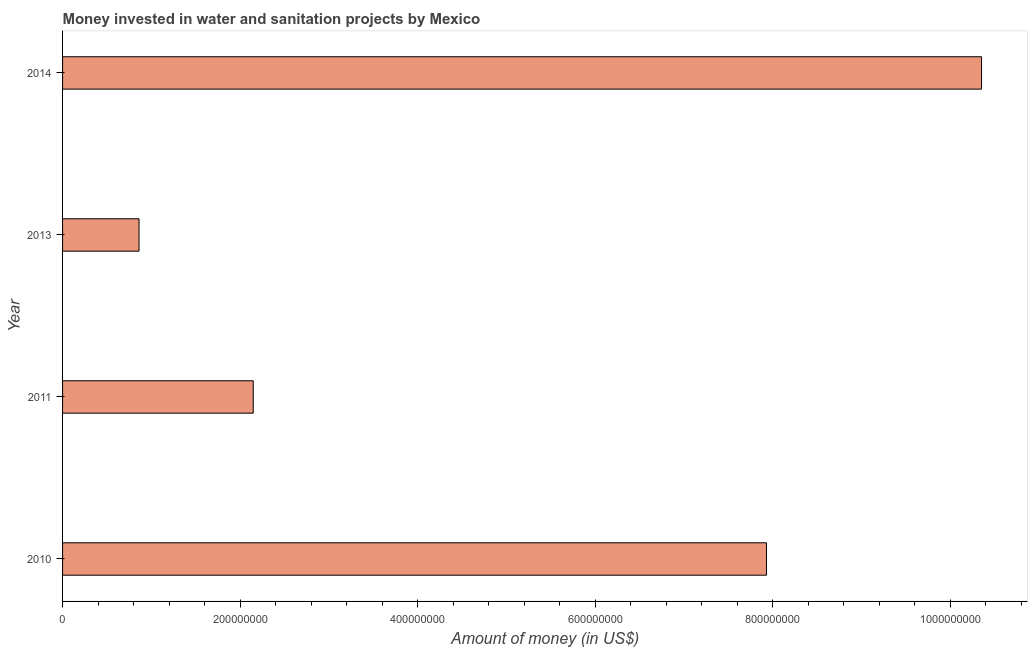What is the title of the graph?
Your answer should be very brief. Money invested in water and sanitation projects by Mexico. What is the label or title of the X-axis?
Ensure brevity in your answer.  Amount of money (in US$). What is the label or title of the Y-axis?
Make the answer very short. Year. What is the investment in 2011?
Provide a short and direct response. 2.15e+08. Across all years, what is the maximum investment?
Make the answer very short. 1.04e+09. Across all years, what is the minimum investment?
Provide a succinct answer. 8.62e+07. What is the sum of the investment?
Give a very brief answer. 2.13e+09. What is the difference between the investment in 2010 and 2014?
Ensure brevity in your answer.  -2.42e+08. What is the average investment per year?
Your answer should be very brief. 5.32e+08. What is the median investment?
Provide a short and direct response. 5.04e+08. Do a majority of the years between 2011 and 2013 (inclusive) have investment greater than 560000000 US$?
Your answer should be compact. No. What is the ratio of the investment in 2010 to that in 2013?
Offer a very short reply. 9.21. Is the difference between the investment in 2010 and 2013 greater than the difference between any two years?
Provide a succinct answer. No. What is the difference between the highest and the second highest investment?
Keep it short and to the point. 2.42e+08. Is the sum of the investment in 2010 and 2014 greater than the maximum investment across all years?
Make the answer very short. Yes. What is the difference between the highest and the lowest investment?
Give a very brief answer. 9.49e+08. How many years are there in the graph?
Give a very brief answer. 4. What is the difference between two consecutive major ticks on the X-axis?
Ensure brevity in your answer.  2.00e+08. What is the Amount of money (in US$) of 2010?
Offer a terse response. 7.93e+08. What is the Amount of money (in US$) of 2011?
Provide a short and direct response. 2.15e+08. What is the Amount of money (in US$) of 2013?
Make the answer very short. 8.62e+07. What is the Amount of money (in US$) of 2014?
Give a very brief answer. 1.04e+09. What is the difference between the Amount of money (in US$) in 2010 and 2011?
Ensure brevity in your answer.  5.78e+08. What is the difference between the Amount of money (in US$) in 2010 and 2013?
Provide a short and direct response. 7.07e+08. What is the difference between the Amount of money (in US$) in 2010 and 2014?
Keep it short and to the point. -2.42e+08. What is the difference between the Amount of money (in US$) in 2011 and 2013?
Give a very brief answer. 1.29e+08. What is the difference between the Amount of money (in US$) in 2011 and 2014?
Offer a terse response. -8.20e+08. What is the difference between the Amount of money (in US$) in 2013 and 2014?
Offer a terse response. -9.49e+08. What is the ratio of the Amount of money (in US$) in 2010 to that in 2011?
Ensure brevity in your answer.  3.69. What is the ratio of the Amount of money (in US$) in 2010 to that in 2013?
Your answer should be compact. 9.21. What is the ratio of the Amount of money (in US$) in 2010 to that in 2014?
Offer a terse response. 0.77. What is the ratio of the Amount of money (in US$) in 2011 to that in 2013?
Provide a short and direct response. 2.49. What is the ratio of the Amount of money (in US$) in 2011 to that in 2014?
Your response must be concise. 0.21. What is the ratio of the Amount of money (in US$) in 2013 to that in 2014?
Offer a very short reply. 0.08. 